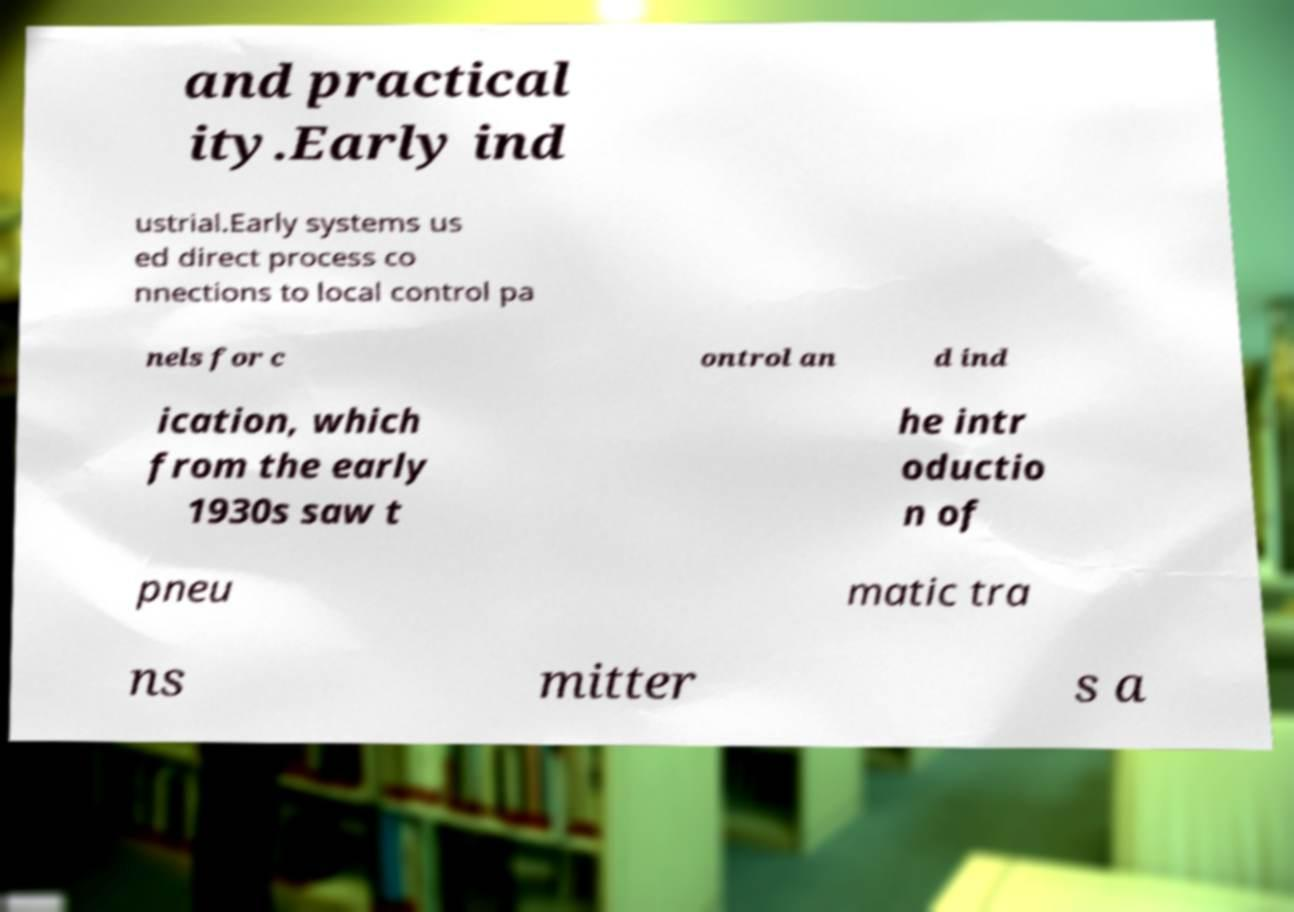I need the written content from this picture converted into text. Can you do that? and practical ity.Early ind ustrial.Early systems us ed direct process co nnections to local control pa nels for c ontrol an d ind ication, which from the early 1930s saw t he intr oductio n of pneu matic tra ns mitter s a 